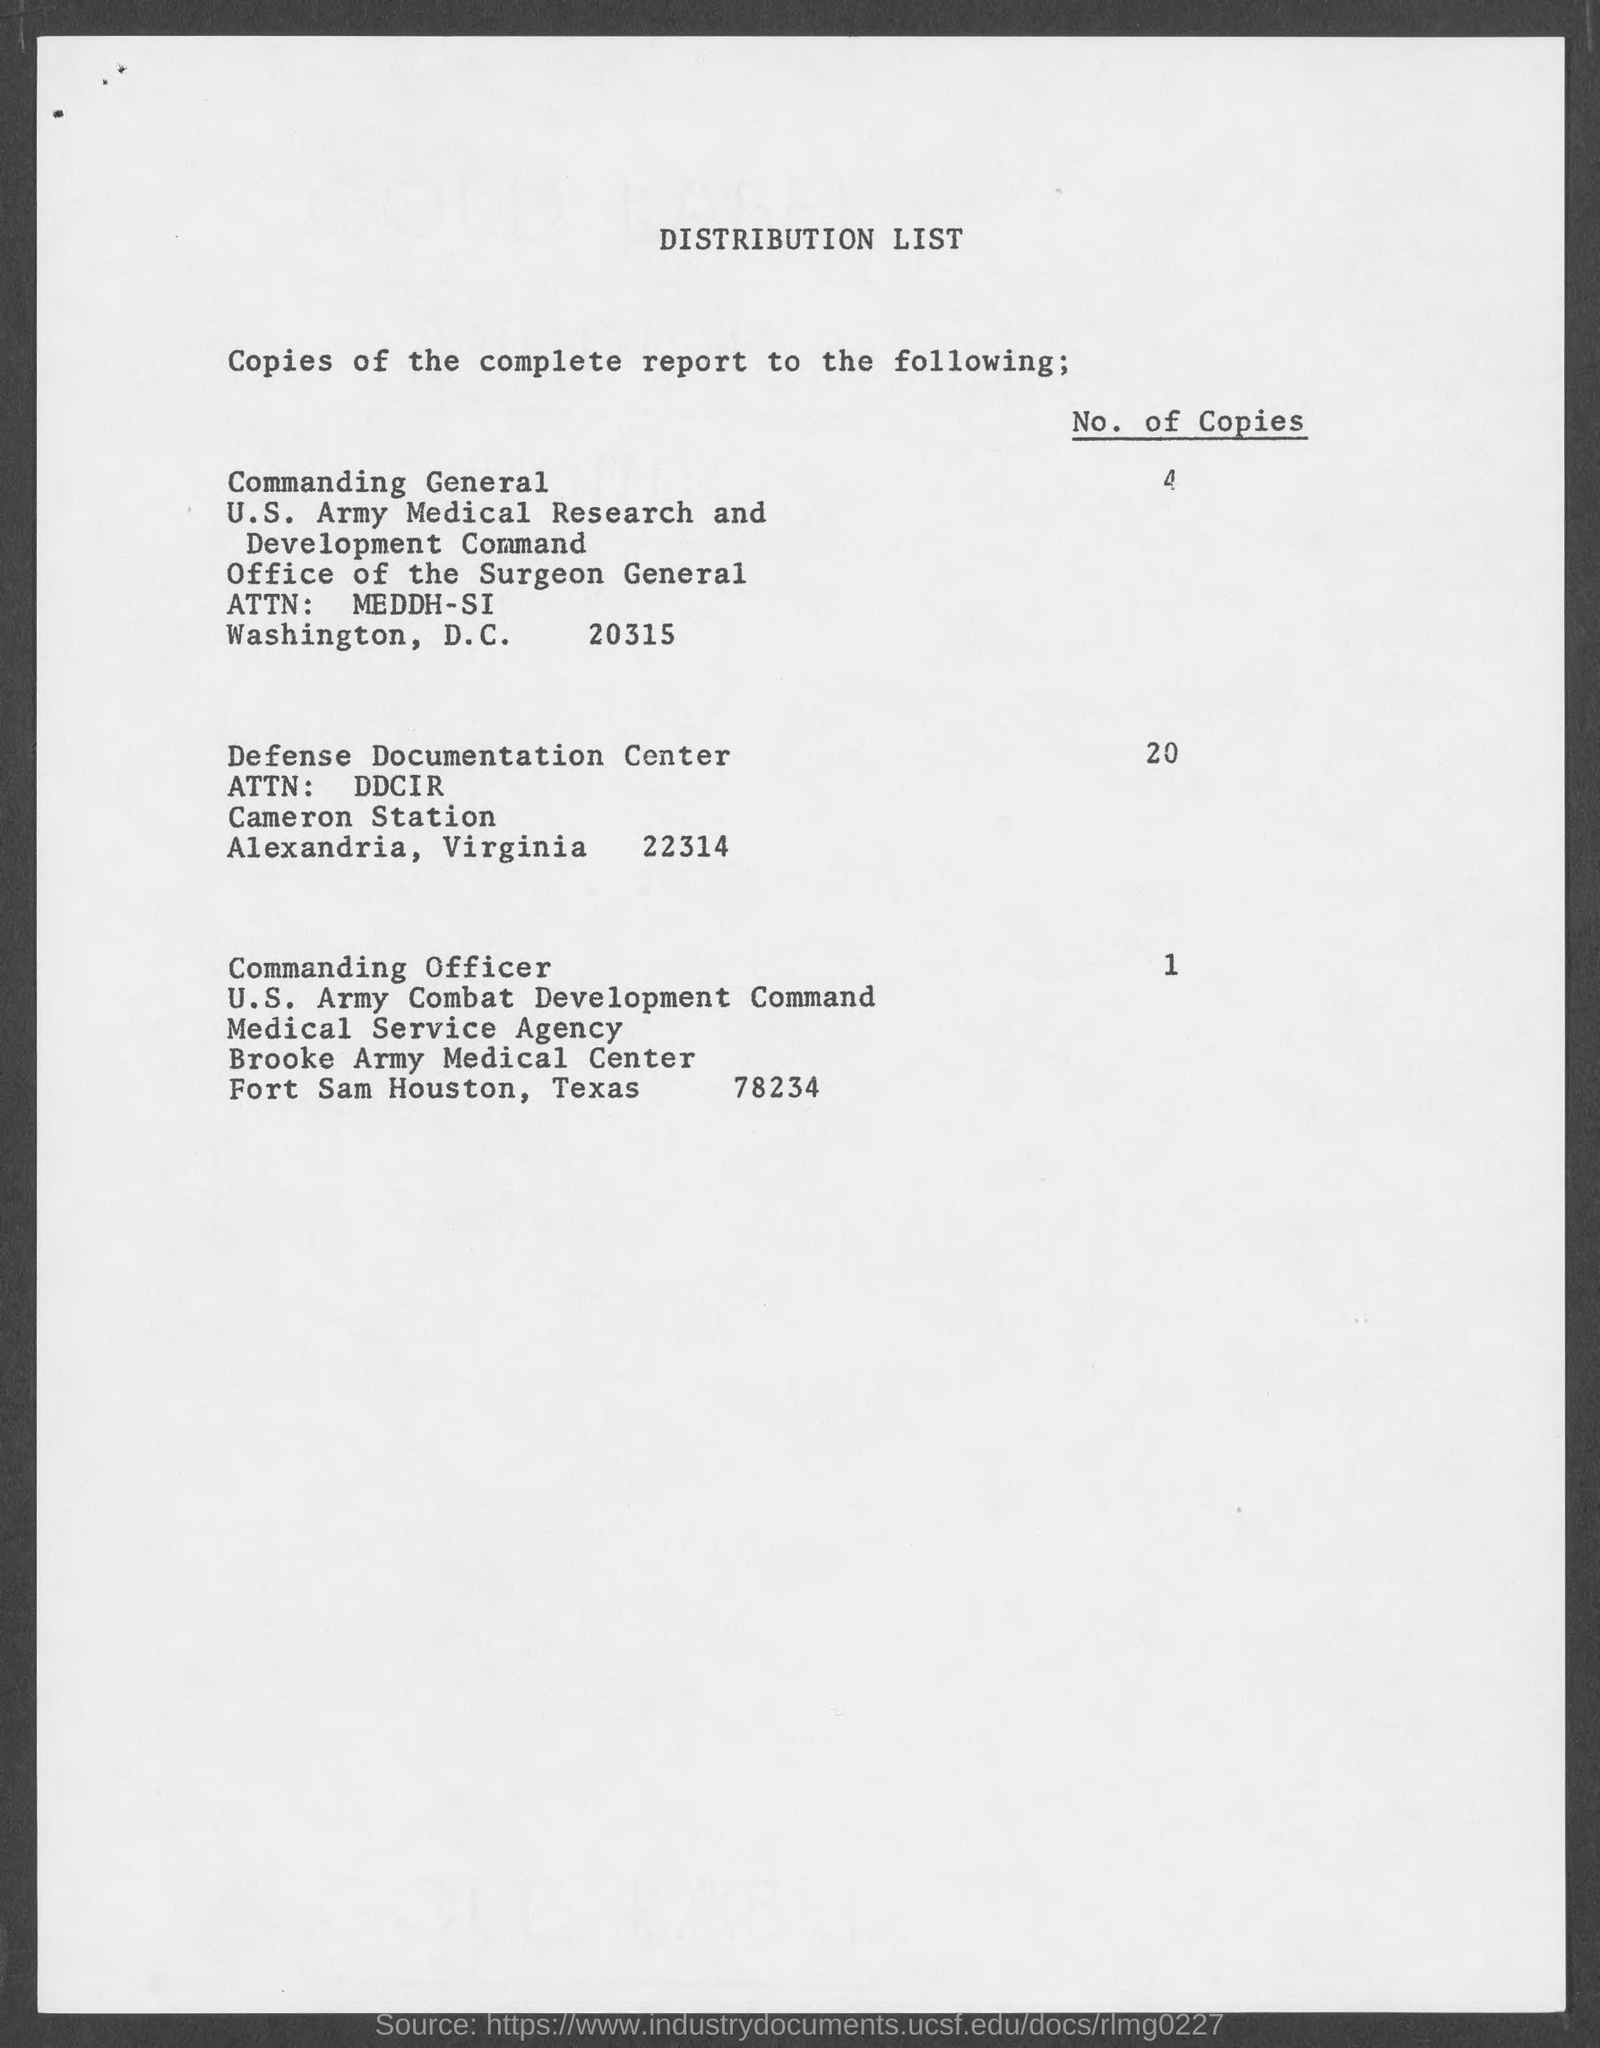Can you give me the ZIP code for the Defense Documentation Center listed in the document? The ZIP code for the Defense Documentation Center listed is 22314. 